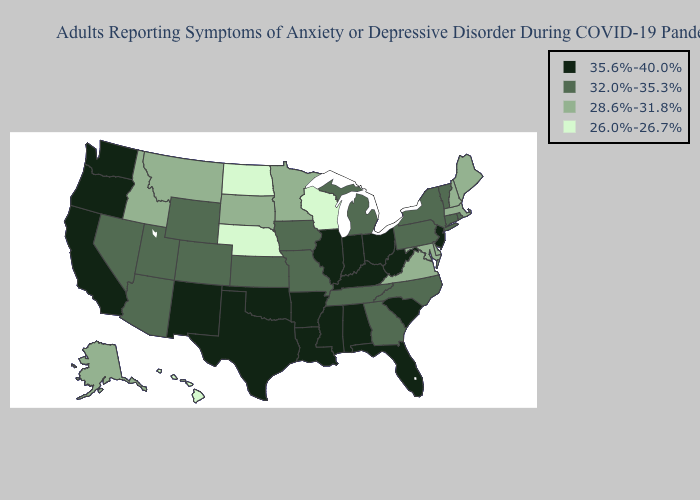What is the value of Wyoming?
Keep it brief. 32.0%-35.3%. Does Hawaii have the lowest value in the West?
Write a very short answer. Yes. Among the states that border Nebraska , which have the lowest value?
Answer briefly. South Dakota. Does Colorado have the same value as Virginia?
Write a very short answer. No. What is the highest value in states that border Ohio?
Quick response, please. 35.6%-40.0%. What is the value of Illinois?
Short answer required. 35.6%-40.0%. Name the states that have a value in the range 35.6%-40.0%?
Short answer required. Alabama, Arkansas, California, Florida, Illinois, Indiana, Kentucky, Louisiana, Mississippi, New Jersey, New Mexico, Ohio, Oklahoma, Oregon, South Carolina, Texas, Washington, West Virginia. What is the lowest value in states that border New Hampshire?
Keep it brief. 28.6%-31.8%. Name the states that have a value in the range 35.6%-40.0%?
Concise answer only. Alabama, Arkansas, California, Florida, Illinois, Indiana, Kentucky, Louisiana, Mississippi, New Jersey, New Mexico, Ohio, Oklahoma, Oregon, South Carolina, Texas, Washington, West Virginia. Name the states that have a value in the range 32.0%-35.3%?
Be succinct. Arizona, Colorado, Connecticut, Georgia, Iowa, Kansas, Michigan, Missouri, Nevada, New York, North Carolina, Pennsylvania, Rhode Island, Tennessee, Utah, Vermont, Wyoming. What is the value of Wisconsin?
Give a very brief answer. 26.0%-26.7%. Does North Dakota have the highest value in the MidWest?
Write a very short answer. No. What is the highest value in states that border Kansas?
Concise answer only. 35.6%-40.0%. Name the states that have a value in the range 32.0%-35.3%?
Write a very short answer. Arizona, Colorado, Connecticut, Georgia, Iowa, Kansas, Michigan, Missouri, Nevada, New York, North Carolina, Pennsylvania, Rhode Island, Tennessee, Utah, Vermont, Wyoming. What is the value of West Virginia?
Give a very brief answer. 35.6%-40.0%. 